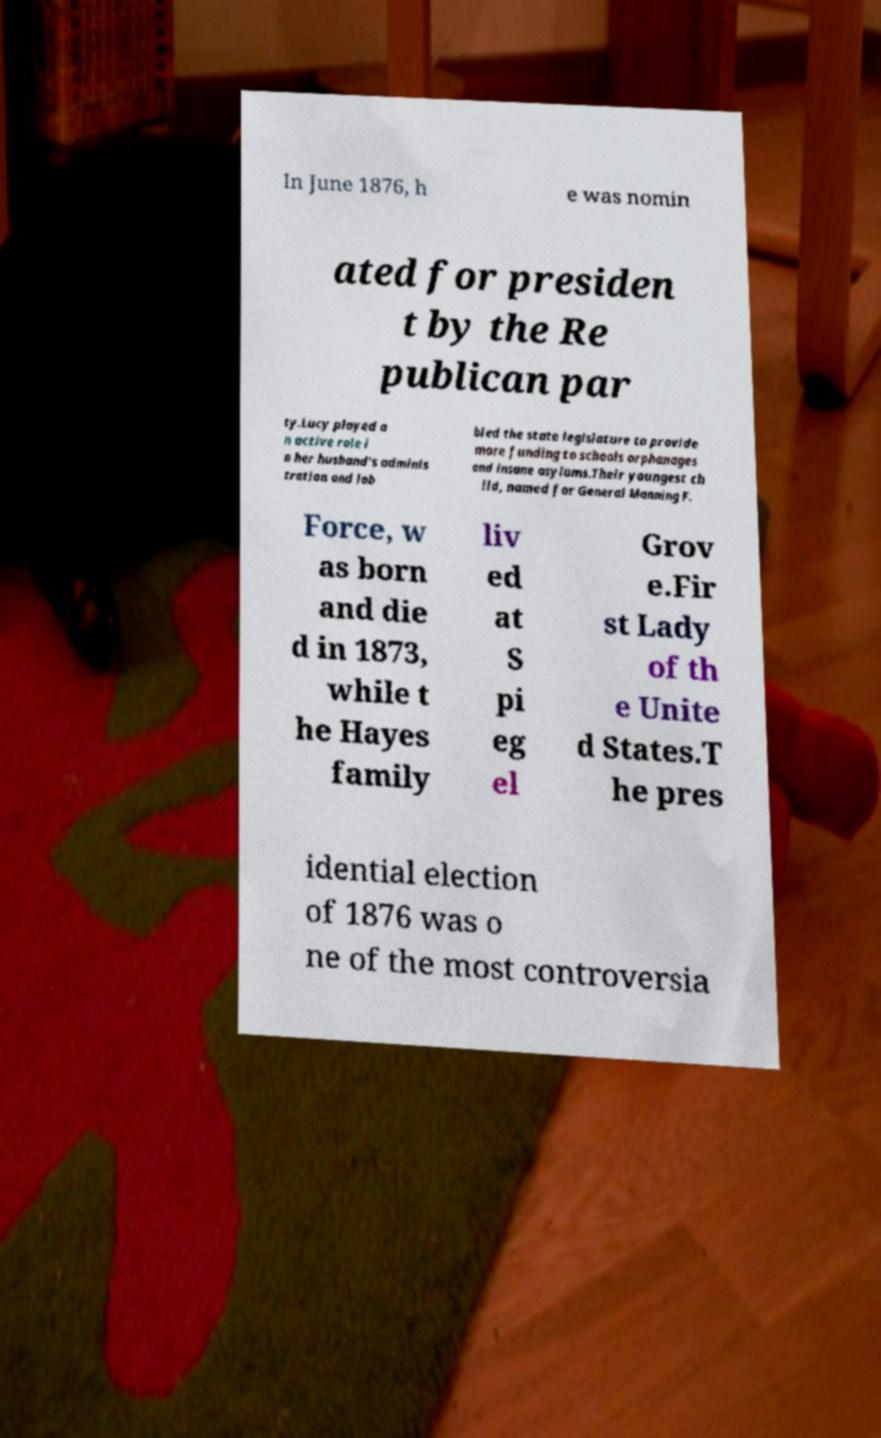Can you read and provide the text displayed in the image?This photo seems to have some interesting text. Can you extract and type it out for me? In June 1876, h e was nomin ated for presiden t by the Re publican par ty.Lucy played a n active role i n her husband's adminis tration and lob bied the state legislature to provide more funding to schools orphanages and insane asylums.Their youngest ch ild, named for General Manning F. Force, w as born and die d in 1873, while t he Hayes family liv ed at S pi eg el Grov e.Fir st Lady of th e Unite d States.T he pres idential election of 1876 was o ne of the most controversia 